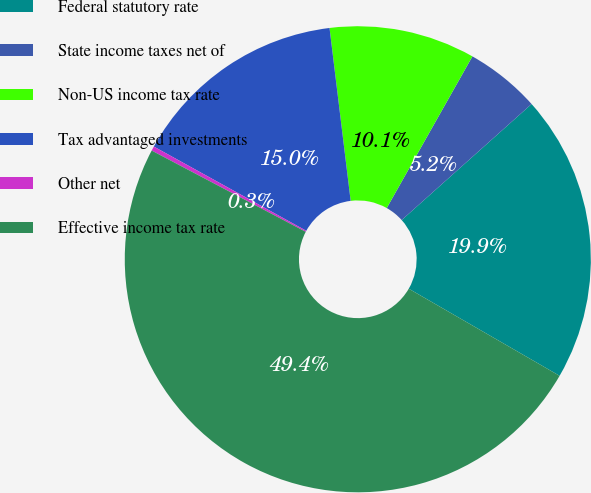Convert chart to OTSL. <chart><loc_0><loc_0><loc_500><loc_500><pie_chart><fcel>Federal statutory rate<fcel>State income taxes net of<fcel>Non-US income tax rate<fcel>Tax advantaged investments<fcel>Other net<fcel>Effective income tax rate<nl><fcel>19.94%<fcel>5.21%<fcel>10.12%<fcel>15.03%<fcel>0.31%<fcel>49.39%<nl></chart> 